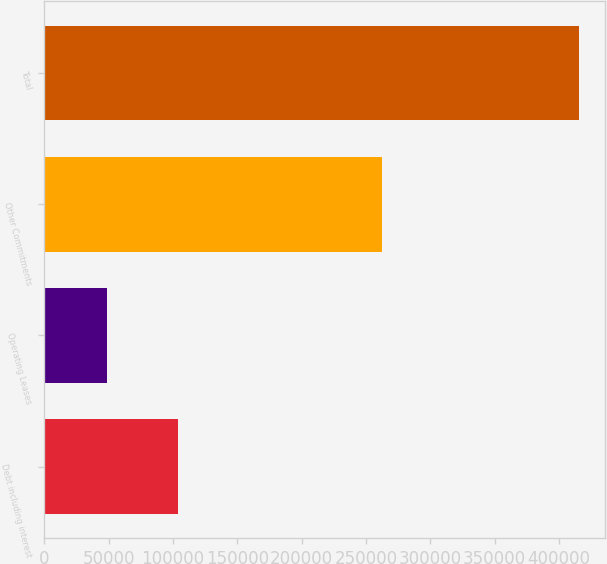Convert chart. <chart><loc_0><loc_0><loc_500><loc_500><bar_chart><fcel>Debt including interest<fcel>Operating Leases<fcel>Other Commitments<fcel>Total<nl><fcel>103750<fcel>49012<fcel>262558<fcel>415320<nl></chart> 